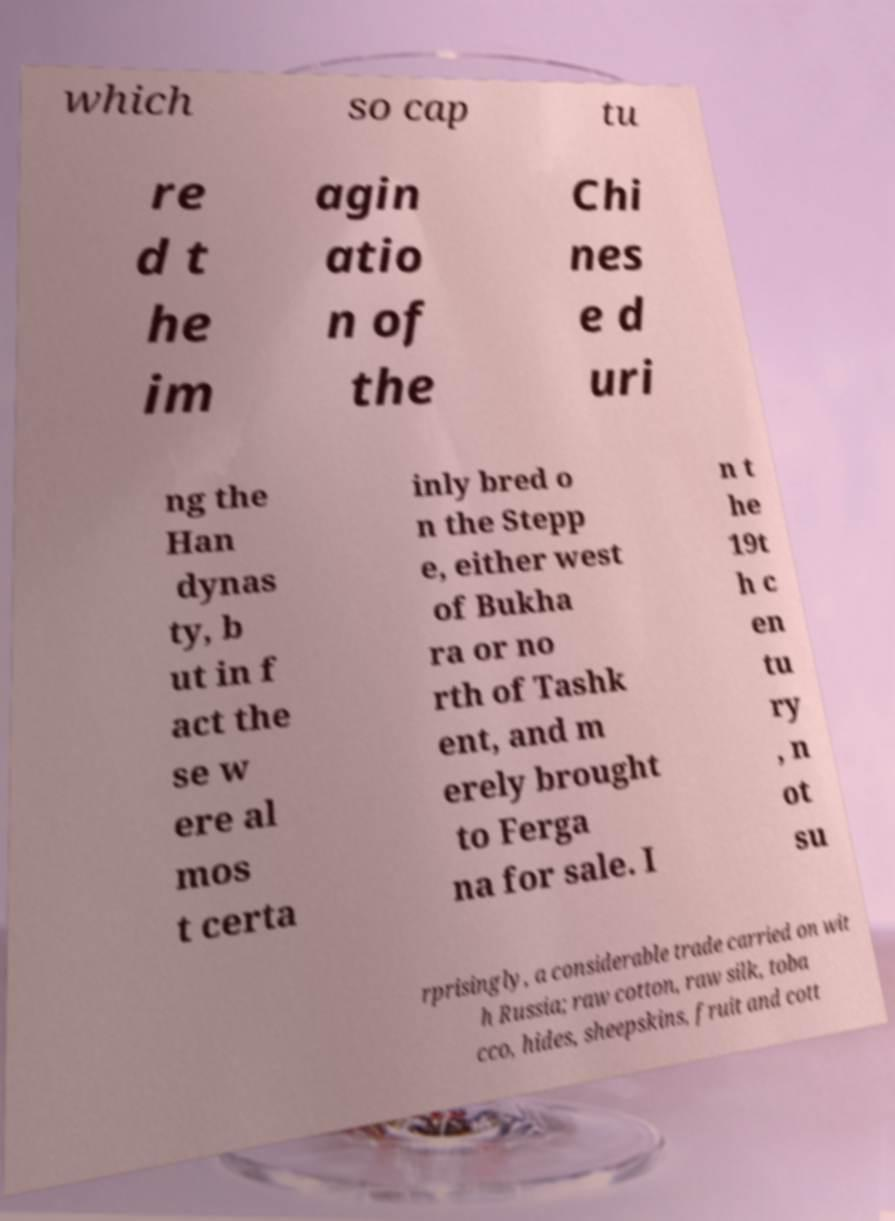Could you assist in decoding the text presented in this image and type it out clearly? which so cap tu re d t he im agin atio n of the Chi nes e d uri ng the Han dynas ty, b ut in f act the se w ere al mos t certa inly bred o n the Stepp e, either west of Bukha ra or no rth of Tashk ent, and m erely brought to Ferga na for sale. I n t he 19t h c en tu ry , n ot su rprisingly, a considerable trade carried on wit h Russia; raw cotton, raw silk, toba cco, hides, sheepskins, fruit and cott 